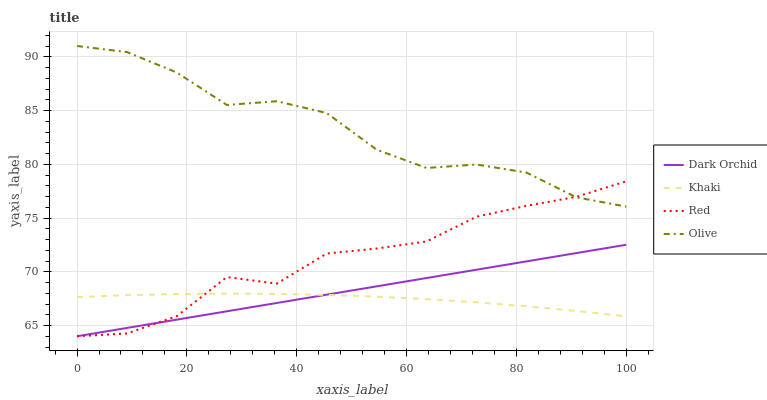Does Khaki have the minimum area under the curve?
Answer yes or no. Yes. Does Olive have the maximum area under the curve?
Answer yes or no. Yes. Does Red have the minimum area under the curve?
Answer yes or no. No. Does Red have the maximum area under the curve?
Answer yes or no. No. Is Dark Orchid the smoothest?
Answer yes or no. Yes. Is Olive the roughest?
Answer yes or no. Yes. Is Khaki the smoothest?
Answer yes or no. No. Is Khaki the roughest?
Answer yes or no. No. Does Red have the lowest value?
Answer yes or no. Yes. Does Khaki have the lowest value?
Answer yes or no. No. Does Olive have the highest value?
Answer yes or no. Yes. Does Red have the highest value?
Answer yes or no. No. Is Khaki less than Olive?
Answer yes or no. Yes. Is Olive greater than Khaki?
Answer yes or no. Yes. Does Dark Orchid intersect Khaki?
Answer yes or no. Yes. Is Dark Orchid less than Khaki?
Answer yes or no. No. Is Dark Orchid greater than Khaki?
Answer yes or no. No. Does Khaki intersect Olive?
Answer yes or no. No. 